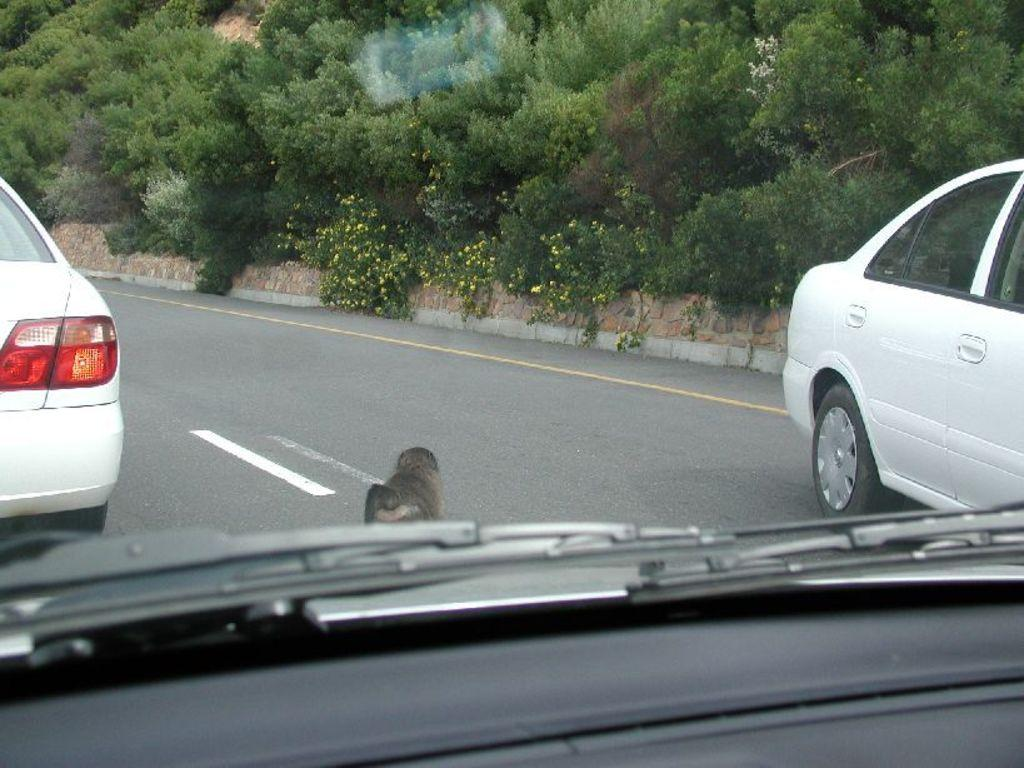What can be seen on the road in the image? There are cars on the road in the image. What type of vegetation is present on the hill in the image? There are plants on a hill in the image. Where is the hill located in the image? The hill is at the top of the image. What type of drawer can be seen in the image? There is no drawer present in the image. How does the achiever wash their hands in the image? There is no achiever or washing activity depicted in the image. 